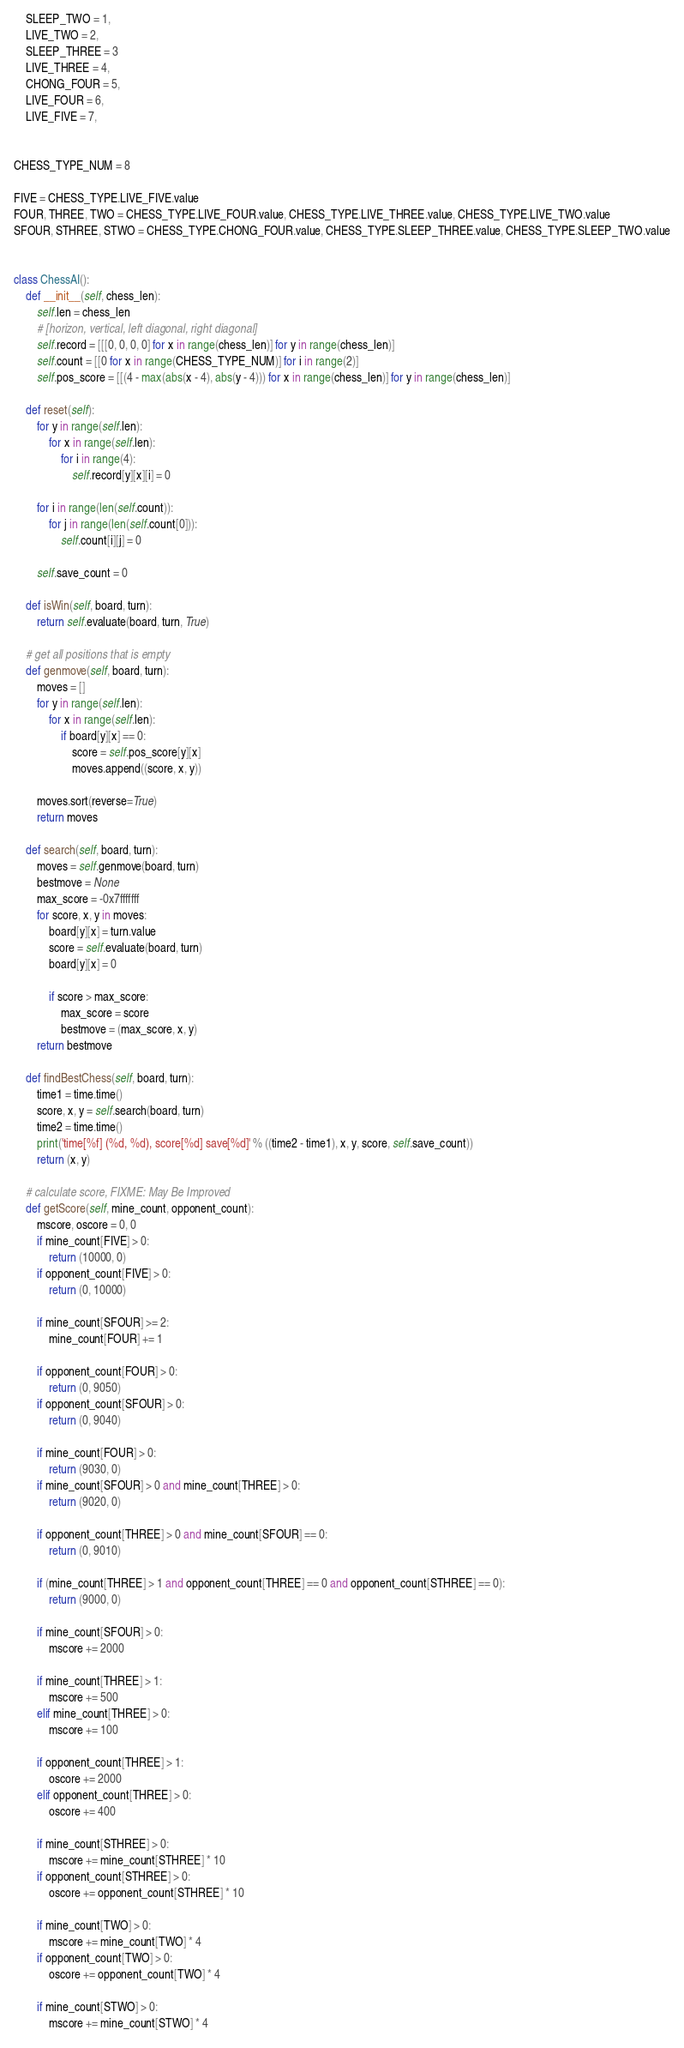Convert code to text. <code><loc_0><loc_0><loc_500><loc_500><_Python_>    SLEEP_TWO = 1,
    LIVE_TWO = 2,
    SLEEP_THREE = 3
    LIVE_THREE = 4,
    CHONG_FOUR = 5,
    LIVE_FOUR = 6,
    LIVE_FIVE = 7,


CHESS_TYPE_NUM = 8

FIVE = CHESS_TYPE.LIVE_FIVE.value
FOUR, THREE, TWO = CHESS_TYPE.LIVE_FOUR.value, CHESS_TYPE.LIVE_THREE.value, CHESS_TYPE.LIVE_TWO.value
SFOUR, STHREE, STWO = CHESS_TYPE.CHONG_FOUR.value, CHESS_TYPE.SLEEP_THREE.value, CHESS_TYPE.SLEEP_TWO.value


class ChessAI():
    def __init__(self, chess_len):
        self.len = chess_len
        # [horizon, vertical, left diagonal, right diagonal]
        self.record = [[[0, 0, 0, 0] for x in range(chess_len)] for y in range(chess_len)]
        self.count = [[0 for x in range(CHESS_TYPE_NUM)] for i in range(2)]
        self.pos_score = [[(4 - max(abs(x - 4), abs(y - 4))) for x in range(chess_len)] for y in range(chess_len)]

    def reset(self):
        for y in range(self.len):
            for x in range(self.len):
                for i in range(4):
                    self.record[y][x][i] = 0

        for i in range(len(self.count)):
            for j in range(len(self.count[0])):
                self.count[i][j] = 0

        self.save_count = 0

    def isWin(self, board, turn):
        return self.evaluate(board, turn, True)

    # get all positions that is empty
    def genmove(self, board, turn):
        moves = []
        for y in range(self.len):
            for x in range(self.len):
                if board[y][x] == 0:
                    score = self.pos_score[y][x]
                    moves.append((score, x, y))

        moves.sort(reverse=True)
        return moves

    def search(self, board, turn):
        moves = self.genmove(board, turn)
        bestmove = None
        max_score = -0x7fffffff
        for score, x, y in moves:
            board[y][x] = turn.value
            score = self.evaluate(board, turn)
            board[y][x] = 0

            if score > max_score:
                max_score = score
                bestmove = (max_score, x, y)
        return bestmove

    def findBestChess(self, board, turn):
        time1 = time.time()
        score, x, y = self.search(board, turn)
        time2 = time.time()
        print('time[%f] (%d, %d), score[%d] save[%d]' % ((time2 - time1), x, y, score, self.save_count))
        return (x, y)

    # calculate score, FIXME: May Be Improved
    def getScore(self, mine_count, opponent_count):
        mscore, oscore = 0, 0
        if mine_count[FIVE] > 0:
            return (10000, 0)
        if opponent_count[FIVE] > 0:
            return (0, 10000)

        if mine_count[SFOUR] >= 2:
            mine_count[FOUR] += 1

        if opponent_count[FOUR] > 0:
            return (0, 9050)
        if opponent_count[SFOUR] > 0:
            return (0, 9040)

        if mine_count[FOUR] > 0:
            return (9030, 0)
        if mine_count[SFOUR] > 0 and mine_count[THREE] > 0:
            return (9020, 0)

        if opponent_count[THREE] > 0 and mine_count[SFOUR] == 0:
            return (0, 9010)

        if (mine_count[THREE] > 1 and opponent_count[THREE] == 0 and opponent_count[STHREE] == 0):
            return (9000, 0)

        if mine_count[SFOUR] > 0:
            mscore += 2000

        if mine_count[THREE] > 1:
            mscore += 500
        elif mine_count[THREE] > 0:
            mscore += 100

        if opponent_count[THREE] > 1:
            oscore += 2000
        elif opponent_count[THREE] > 0:
            oscore += 400

        if mine_count[STHREE] > 0:
            mscore += mine_count[STHREE] * 10
        if opponent_count[STHREE] > 0:
            oscore += opponent_count[STHREE] * 10

        if mine_count[TWO] > 0:
            mscore += mine_count[TWO] * 4
        if opponent_count[TWO] > 0:
            oscore += opponent_count[TWO] * 4

        if mine_count[STWO] > 0:
            mscore += mine_count[STWO] * 4</code> 